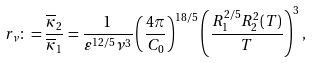Convert formula to latex. <formula><loc_0><loc_0><loc_500><loc_500>r _ { \nu } \colon = \frac { \overline { \kappa } _ { 2 } } { \overline { \kappa } _ { 1 } } = \frac { 1 } { \varepsilon ^ { 1 2 / 5 } \nu ^ { 3 } } \left ( \frac { 4 \pi } { C _ { 0 } } \right ) ^ { 1 8 / 5 } \left ( \frac { R _ { 1 } ^ { 2 / 5 } R _ { 2 } ^ { 2 } ( T ) } { T } \right ) ^ { 3 } ,</formula> 